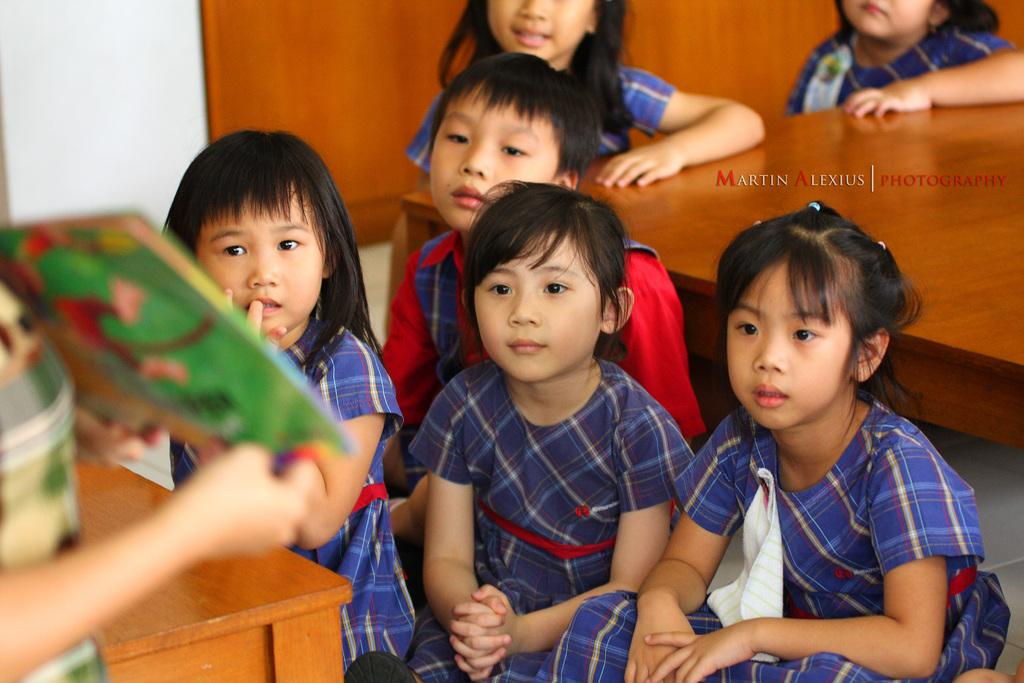What is the main subject of the image? The main subject of the image is a group of kids. Where are the kids sitting in the image? The kids are sitting on a path in the image. Can you describe the person in the image? There is a person holding an object in the image. What can be seen in the background of the image? There is a wooden table and a wall in the background of the image. What type of cactus can be seen growing near the wooden table in the image? There is no cactus present in the image; only a wooden table and a wall are visible in the background. 